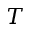Convert formula to latex. <formula><loc_0><loc_0><loc_500><loc_500>T</formula> 